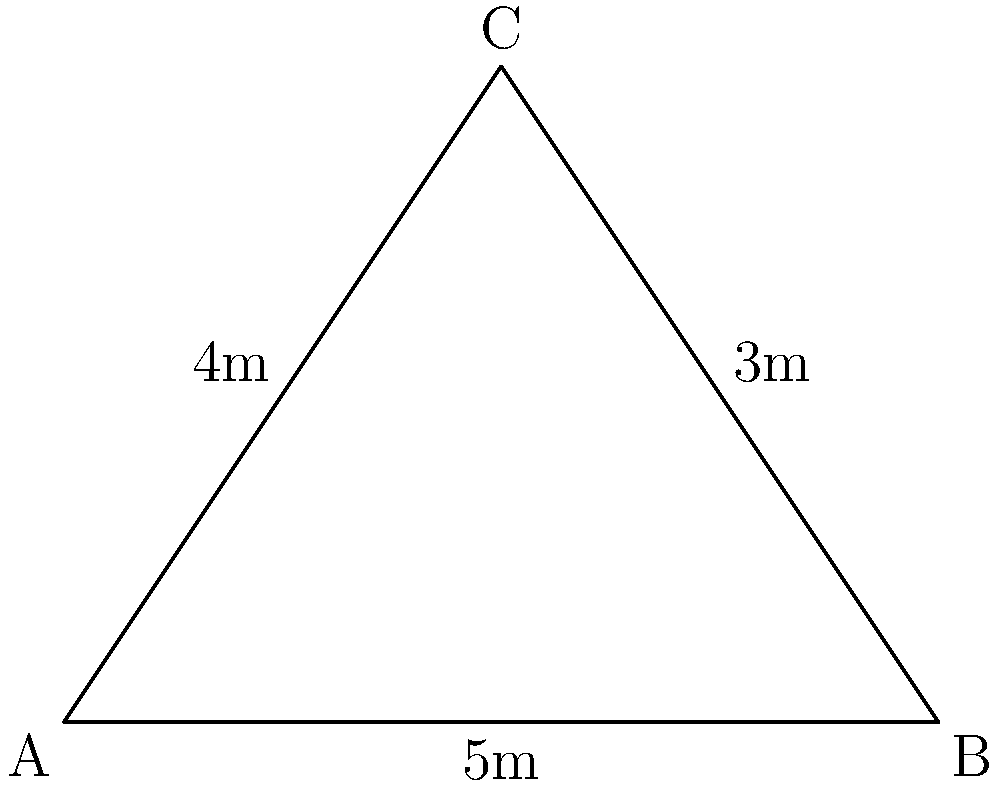A triangular danger zone on a construction site has side lengths of 3m, 4m, and 5m. What is the perimeter of this danger zone? To find the perimeter of the triangular danger zone, we need to sum up the lengths of all sides:

1. Given side lengths:
   - Side 1: 3m
   - Side 2: 4m
   - Side 3: 5m

2. Calculate the perimeter:
   $$\text{Perimeter} = \text{Side 1} + \text{Side 2} + \text{Side 3}$$
   $$\text{Perimeter} = 3\text{m} + 4\text{m} + 5\text{m}$$
   $$\text{Perimeter} = 12\text{m}$$

Therefore, the perimeter of the triangular danger zone is 12 meters.
Answer: 12m 